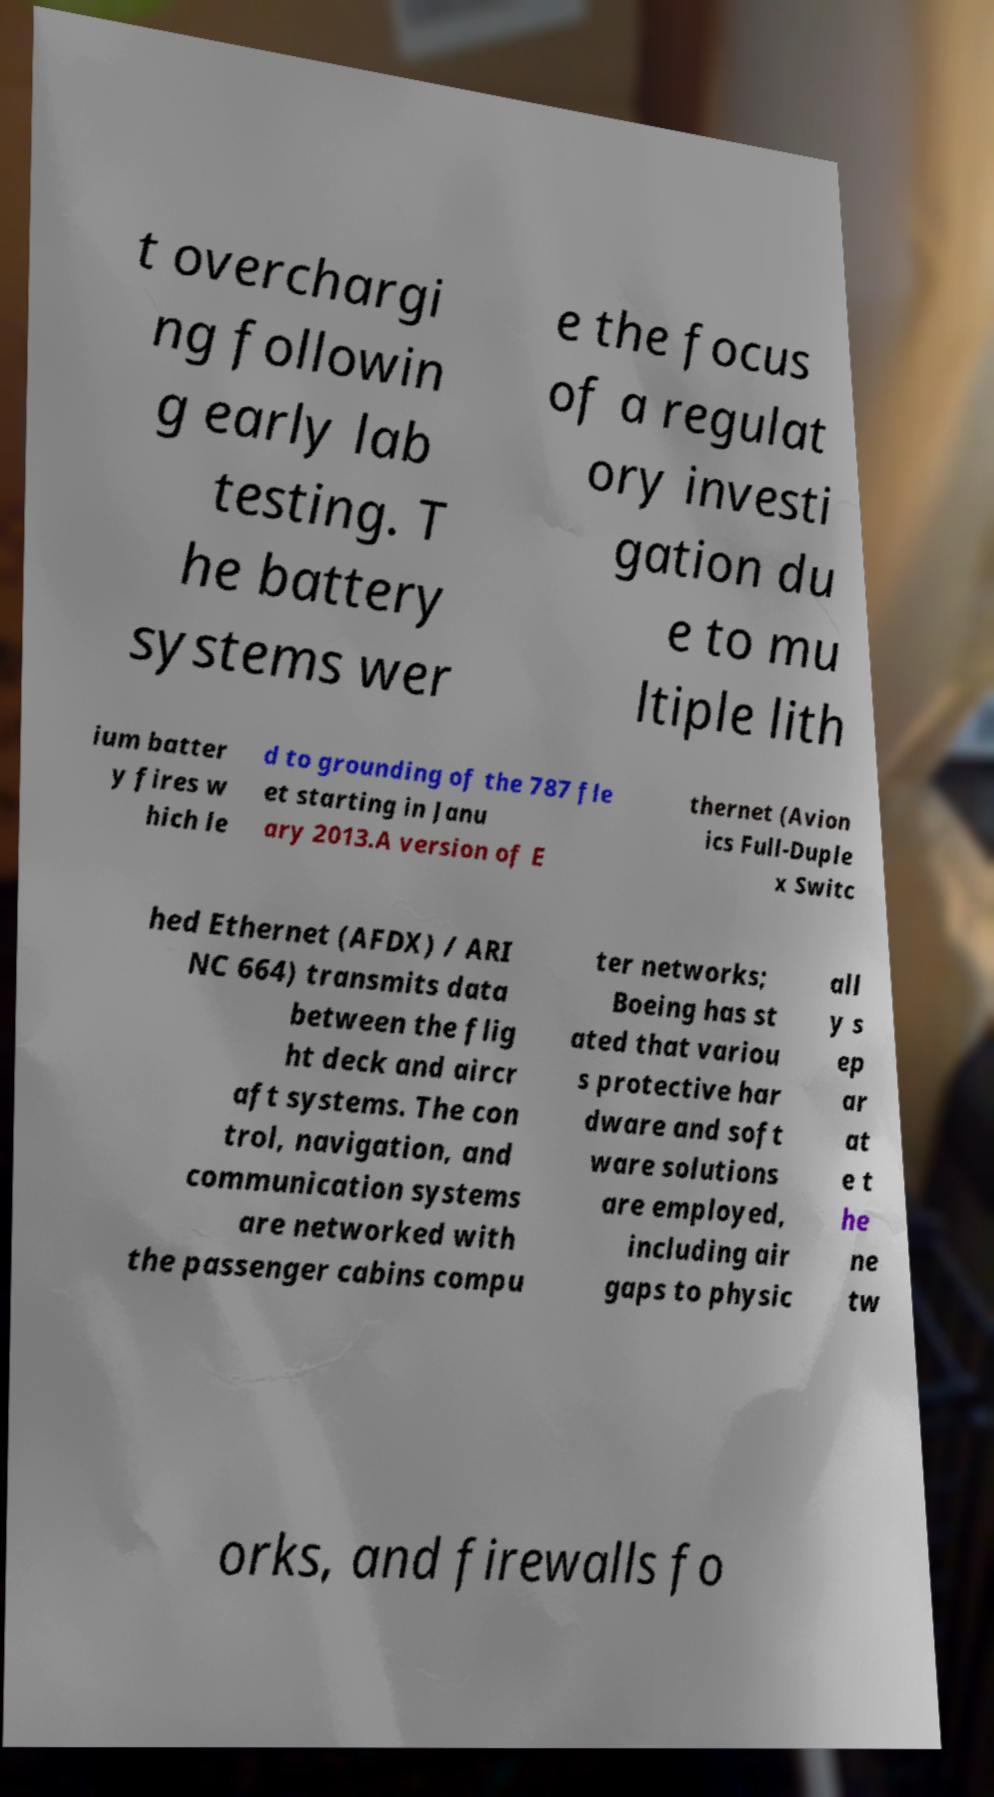I need the written content from this picture converted into text. Can you do that? t overchargi ng followin g early lab testing. T he battery systems wer e the focus of a regulat ory investi gation du e to mu ltiple lith ium batter y fires w hich le d to grounding of the 787 fle et starting in Janu ary 2013.A version of E thernet (Avion ics Full-Duple x Switc hed Ethernet (AFDX) / ARI NC 664) transmits data between the flig ht deck and aircr aft systems. The con trol, navigation, and communication systems are networked with the passenger cabins compu ter networks; Boeing has st ated that variou s protective har dware and soft ware solutions are employed, including air gaps to physic all y s ep ar at e t he ne tw orks, and firewalls fo 